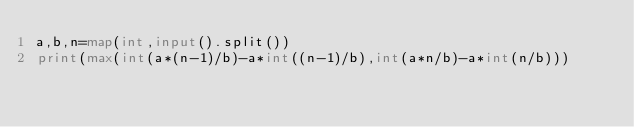<code> <loc_0><loc_0><loc_500><loc_500><_Python_>a,b,n=map(int,input().split())
print(max(int(a*(n-1)/b)-a*int((n-1)/b),int(a*n/b)-a*int(n/b)))</code> 